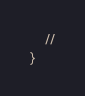<code> <loc_0><loc_0><loc_500><loc_500><_PHP_>    //
}
</code> 